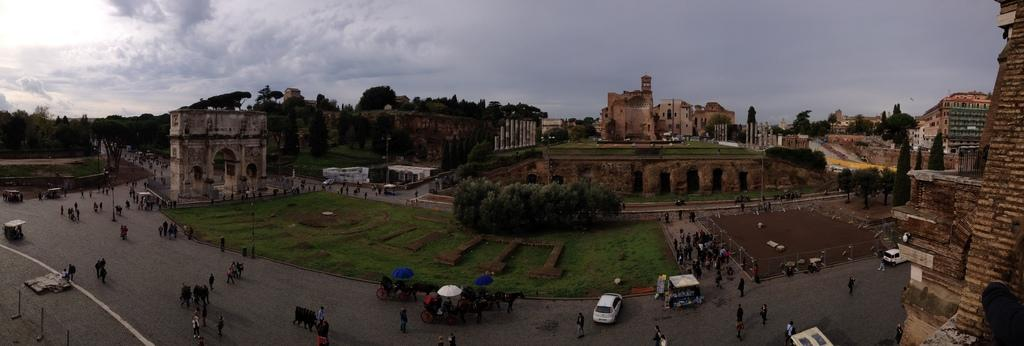What type of structure is present in the image? There is a fort in the image. Can you describe any specific architectural features in the image? There is an arch in the image. What type of natural elements can be seen in the image? There are trees in the image. Are there any people present in the image? Yes, there are persons in the image. What type of pathway is visible in the image? There is a road in the image. What mode of transportation can be seen in the image? There are vehicles in the image. What type of accessory is present in the image? There is an umbrella in the image. What type of man-made structures are present in the image? There are buildings in the image. What can be seen in the sky in the image? The sky is visible in the image, and there are clouds in the image. How many rifles are visible in the image? There are no rifles present in the image. What type of van is parked near the fort in the image? There is no van present in the image. 